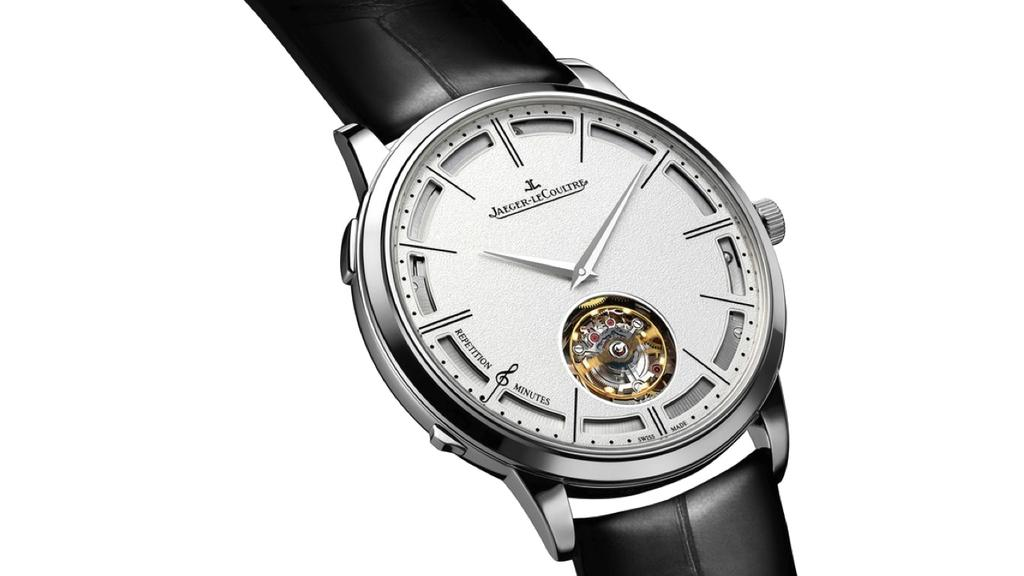<image>
Create a compact narrative representing the image presented. A Jaeger LeCoultre watch is shown with a black band. 